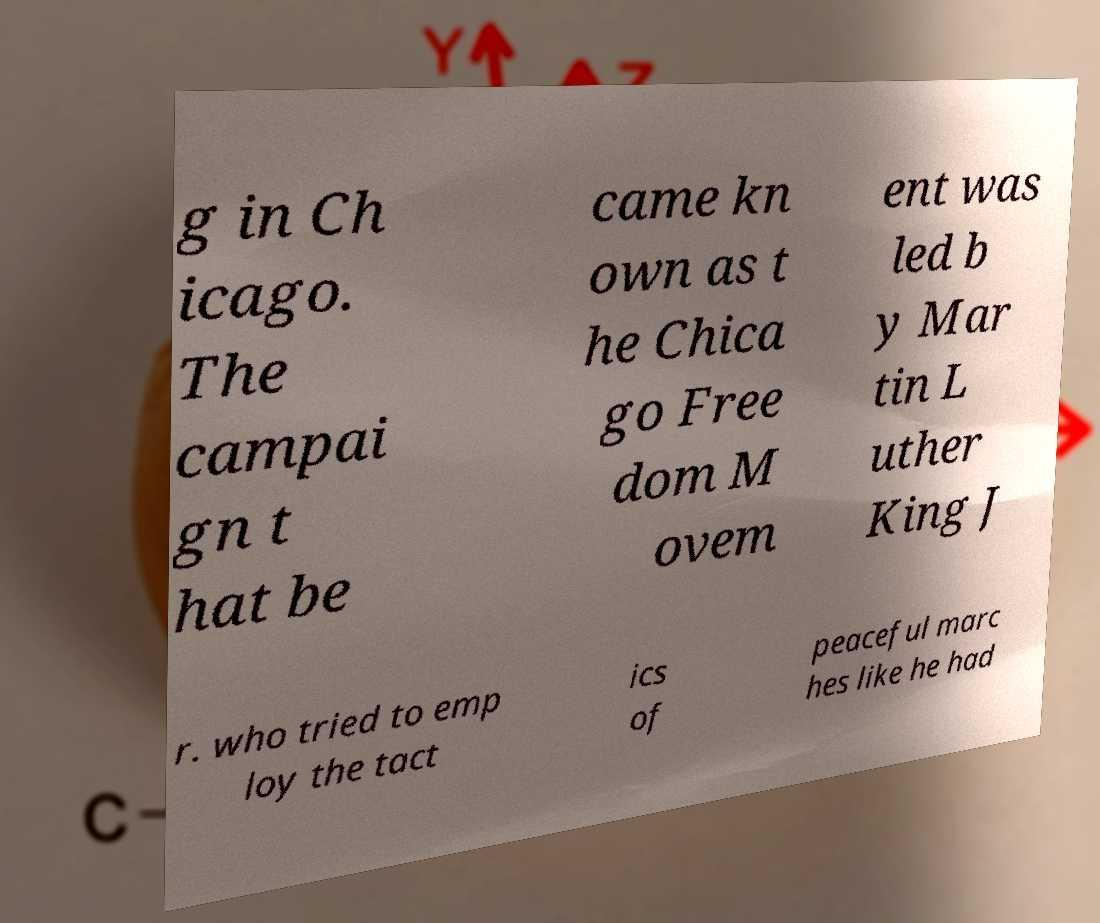Can you read and provide the text displayed in the image?This photo seems to have some interesting text. Can you extract and type it out for me? g in Ch icago. The campai gn t hat be came kn own as t he Chica go Free dom M ovem ent was led b y Mar tin L uther King J r. who tried to emp loy the tact ics of peaceful marc hes like he had 